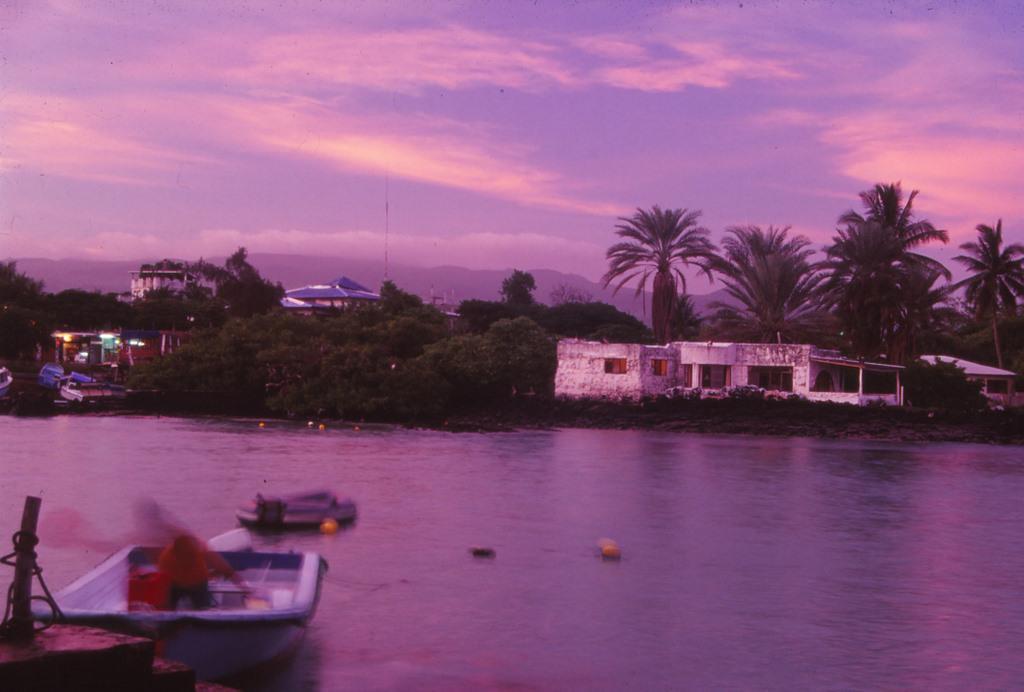Can you describe this image briefly? In this image we can see some boats in a water and some other objects. We can see some trees and buildings and the sky with clouds. 